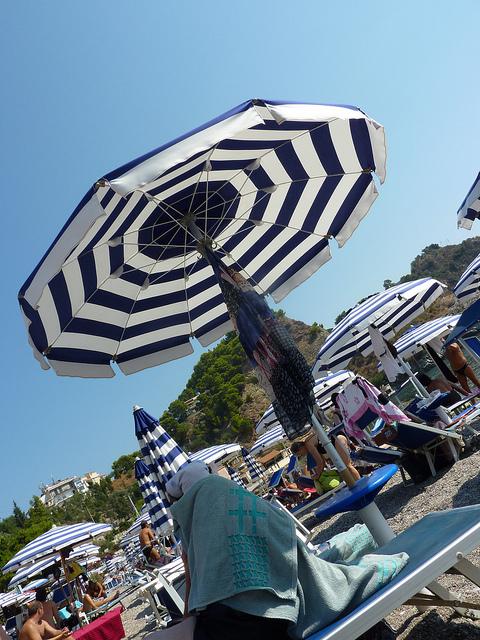What is black and white?
Quick response, please. Umbrella. What color is the umbrellas?
Keep it brief. Black and white. How many humans are shown?
Short answer required. 6. 